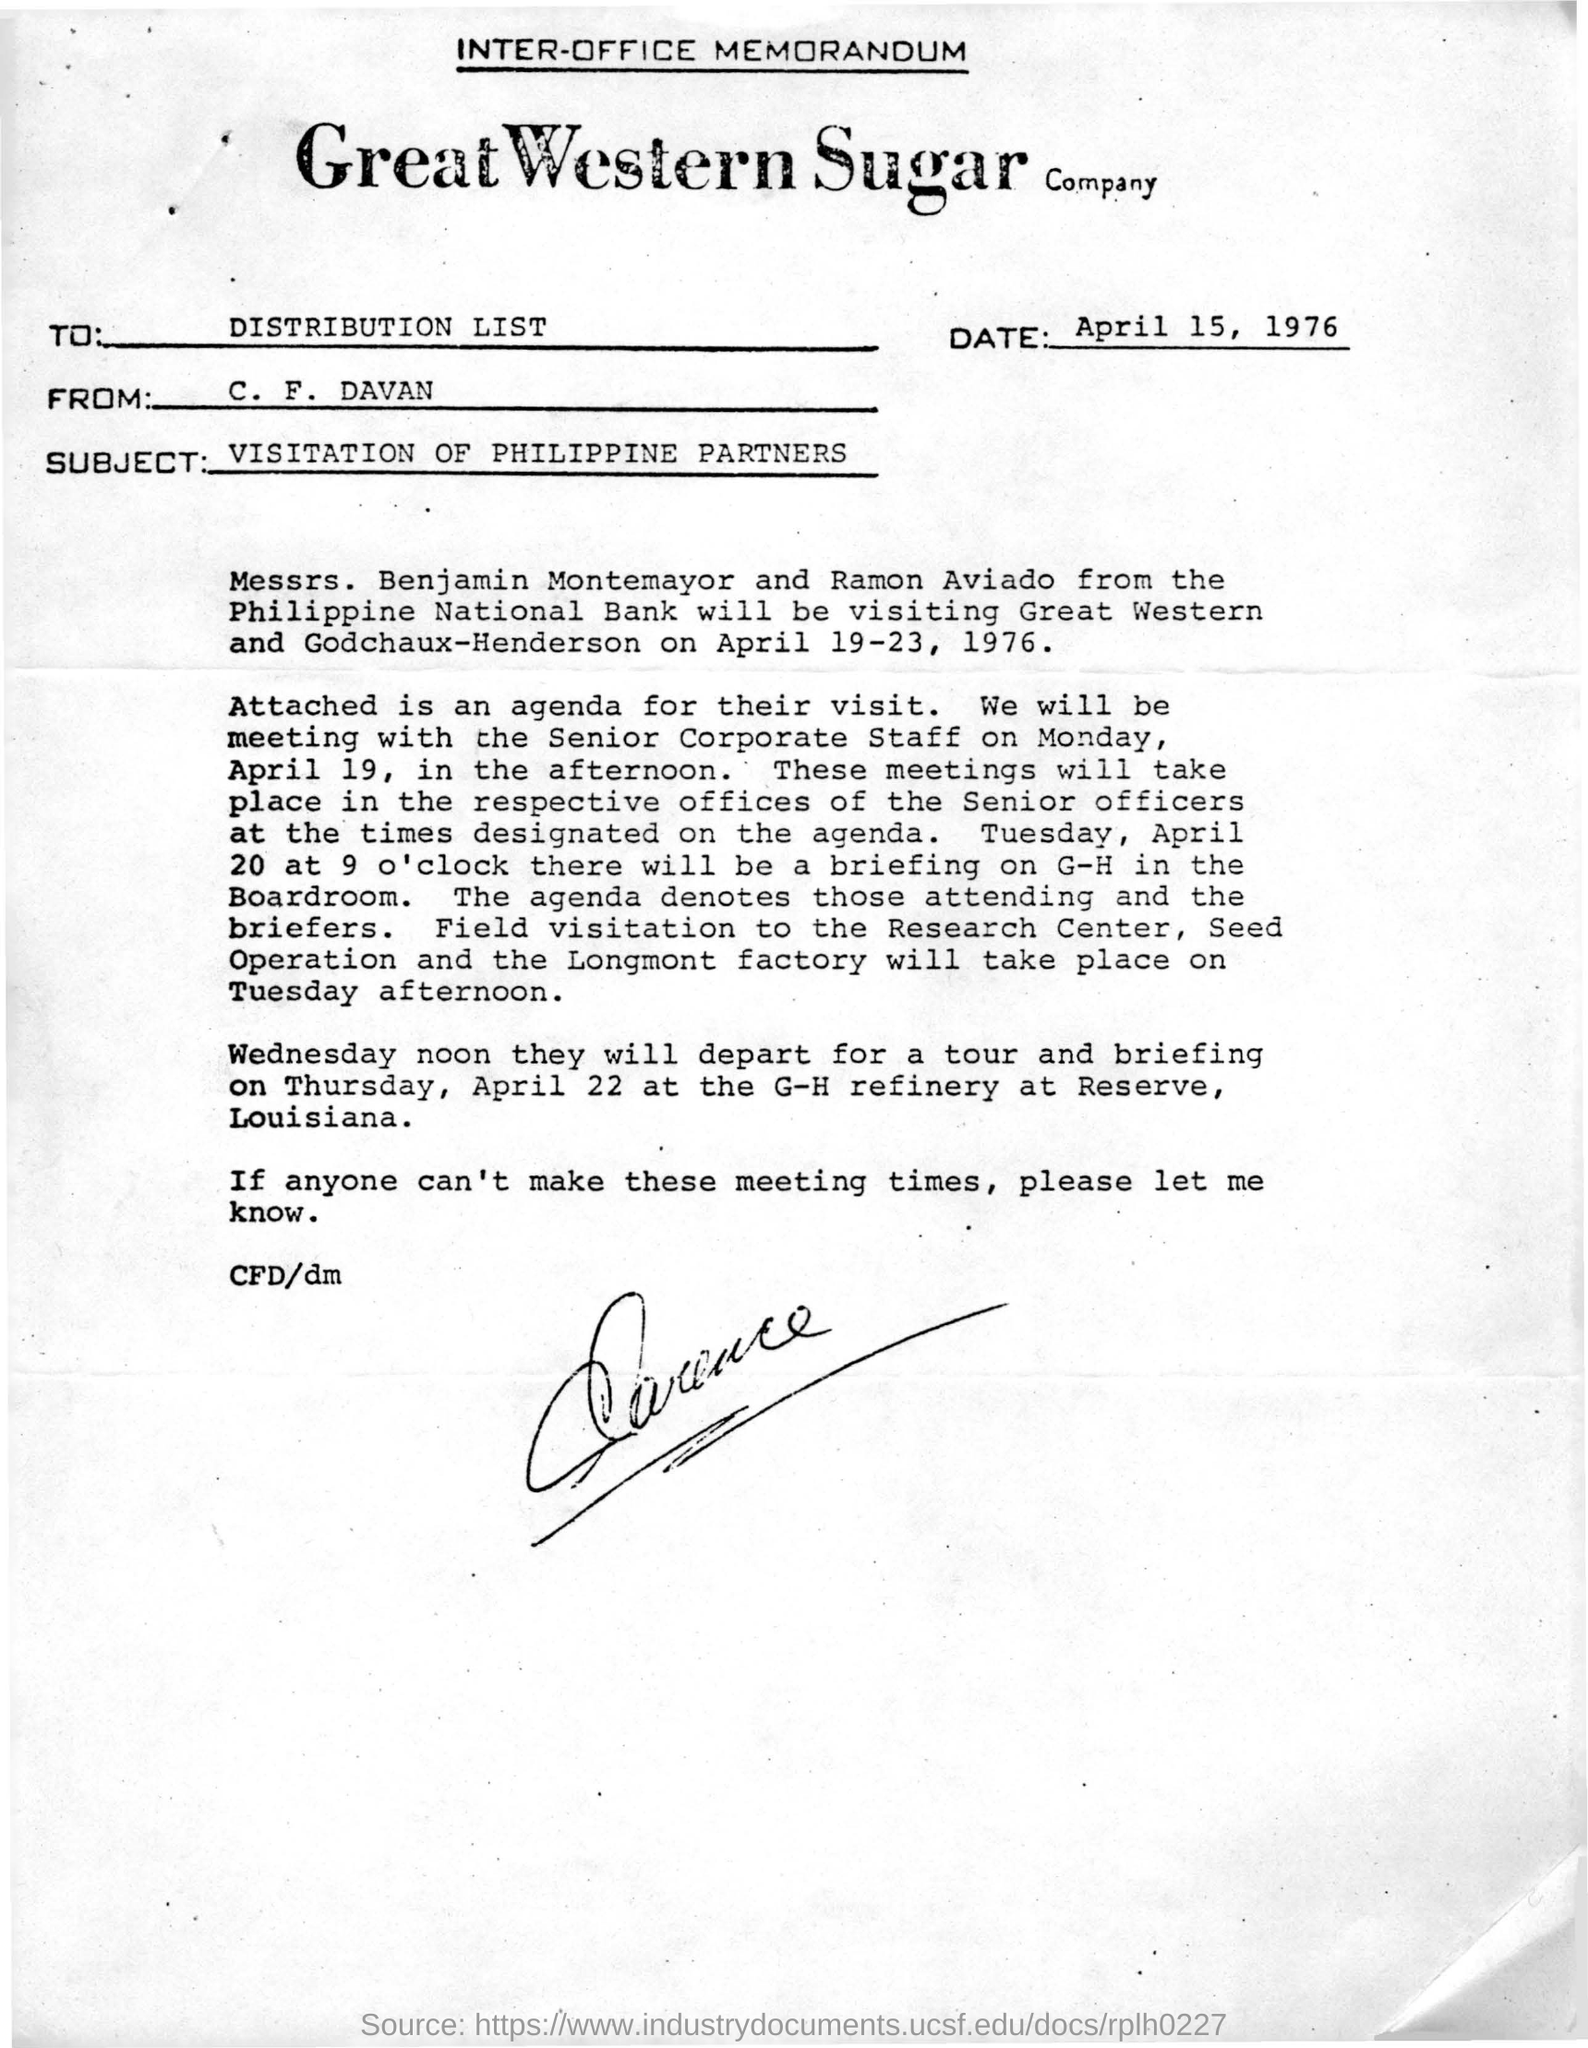Who is the sender of this memorandum?
Provide a succinct answer. C. F. DAVAN. When is the memorandum dated on?
Keep it short and to the point. April 15, 1976. Where are Messrs. Benjamin montemayor and Ramon Aviado from?
Your answer should be very brief. Philippine National Bank. When are Messrs. Benjamin montemayor and Ramon Aviado from the Philippine National bank visiting Great Western and Godchaux-Henderson?
Keep it short and to the point. APRIL 19-23, 1976. 